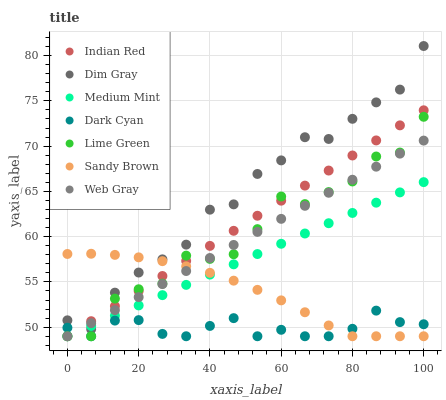Does Dark Cyan have the minimum area under the curve?
Answer yes or no. Yes. Does Dim Gray have the maximum area under the curve?
Answer yes or no. Yes. Does Sandy Brown have the minimum area under the curve?
Answer yes or no. No. Does Sandy Brown have the maximum area under the curve?
Answer yes or no. No. Is Medium Mint the smoothest?
Answer yes or no. Yes. Is Lime Green the roughest?
Answer yes or no. Yes. Is Dim Gray the smoothest?
Answer yes or no. No. Is Dim Gray the roughest?
Answer yes or no. No. Does Medium Mint have the lowest value?
Answer yes or no. Yes. Does Dim Gray have the lowest value?
Answer yes or no. No. Does Dim Gray have the highest value?
Answer yes or no. Yes. Does Sandy Brown have the highest value?
Answer yes or no. No. Is Dark Cyan less than Dim Gray?
Answer yes or no. Yes. Is Dim Gray greater than Dark Cyan?
Answer yes or no. Yes. Does Indian Red intersect Web Gray?
Answer yes or no. Yes. Is Indian Red less than Web Gray?
Answer yes or no. No. Is Indian Red greater than Web Gray?
Answer yes or no. No. Does Dark Cyan intersect Dim Gray?
Answer yes or no. No. 